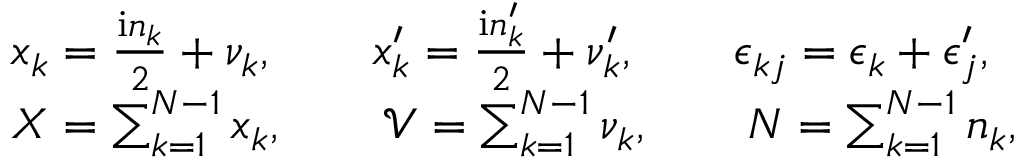<formula> <loc_0><loc_0><loc_500><loc_500>\begin{array} { r l } & { x _ { k } = \frac { i n _ { k } } 2 + \nu _ { k } , \quad x _ { k } ^ { \prime } = \frac { i n _ { k } ^ { \prime } } 2 + \nu _ { k } ^ { \prime } , \quad \epsilon _ { k j } = \epsilon _ { k } + \epsilon _ { j } ^ { \prime } , } \\ & { X = \sum _ { k = 1 } ^ { N - 1 } x _ { k } , \quad \mathcal { V } = \sum _ { k = 1 } ^ { N - 1 } \nu _ { k } , \quad N = \sum _ { k = 1 } ^ { N - 1 } n _ { k } , } \end{array}</formula> 